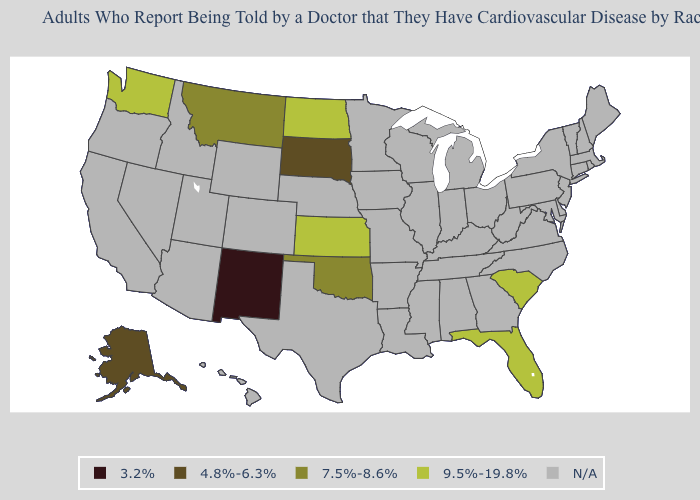Name the states that have a value in the range 7.5%-8.6%?
Give a very brief answer. Montana, Oklahoma. What is the lowest value in the West?
Short answer required. 3.2%. Among the states that border Colorado , which have the highest value?
Concise answer only. Kansas. Does the map have missing data?
Concise answer only. Yes. Name the states that have a value in the range N/A?
Give a very brief answer. Alabama, Arizona, Arkansas, California, Colorado, Connecticut, Delaware, Georgia, Hawaii, Idaho, Illinois, Indiana, Iowa, Kentucky, Louisiana, Maine, Maryland, Massachusetts, Michigan, Minnesota, Mississippi, Missouri, Nebraska, Nevada, New Hampshire, New Jersey, New York, North Carolina, Ohio, Oregon, Pennsylvania, Rhode Island, Tennessee, Texas, Utah, Vermont, Virginia, West Virginia, Wisconsin, Wyoming. Which states have the lowest value in the USA?
Give a very brief answer. New Mexico. What is the value of New York?
Write a very short answer. N/A. What is the value of Missouri?
Concise answer only. N/A. What is the value of Vermont?
Quick response, please. N/A. Does South Carolina have the highest value in the South?
Write a very short answer. Yes. What is the highest value in states that border Utah?
Give a very brief answer. 3.2%. What is the lowest value in the USA?
Give a very brief answer. 3.2%. How many symbols are there in the legend?
Answer briefly. 5. What is the value of California?
Concise answer only. N/A. 